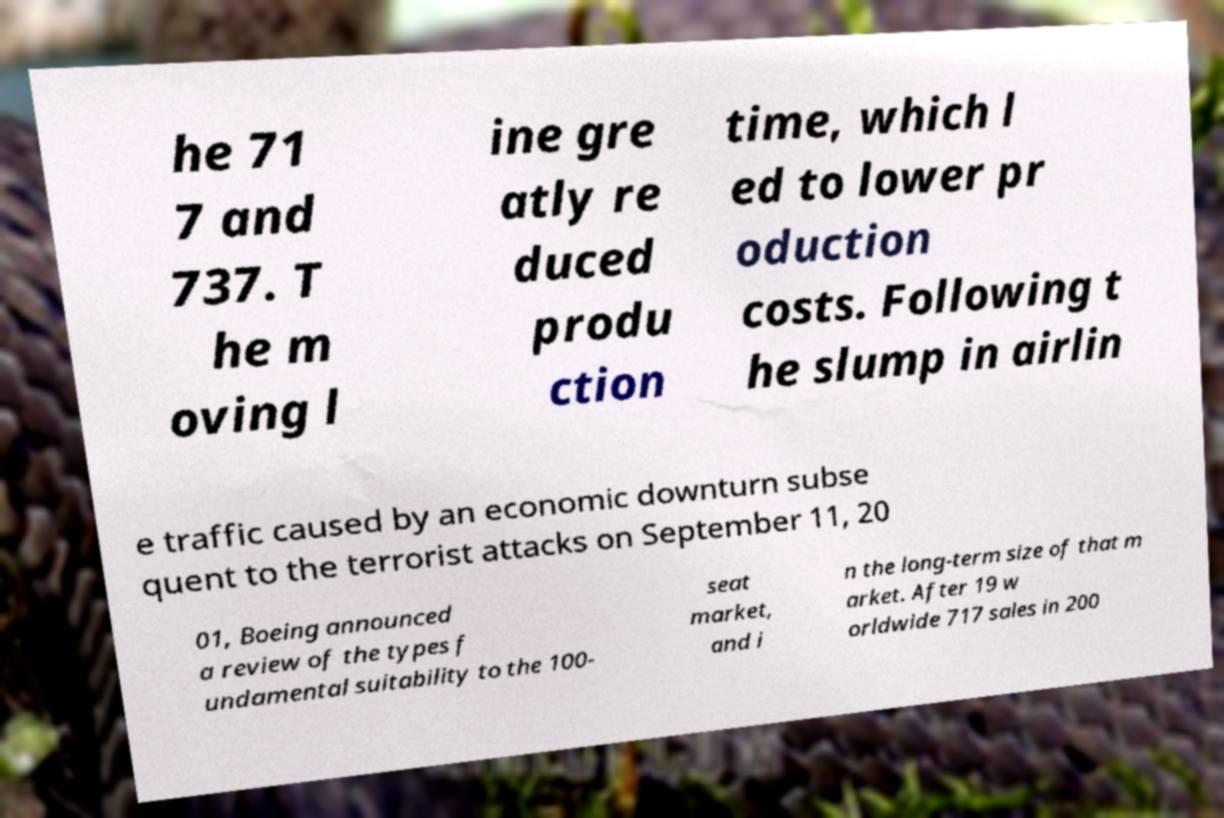Can you accurately transcribe the text from the provided image for me? he 71 7 and 737. T he m oving l ine gre atly re duced produ ction time, which l ed to lower pr oduction costs. Following t he slump in airlin e traffic caused by an economic downturn subse quent to the terrorist attacks on September 11, 20 01, Boeing announced a review of the types f undamental suitability to the 100- seat market, and i n the long-term size of that m arket. After 19 w orldwide 717 sales in 200 